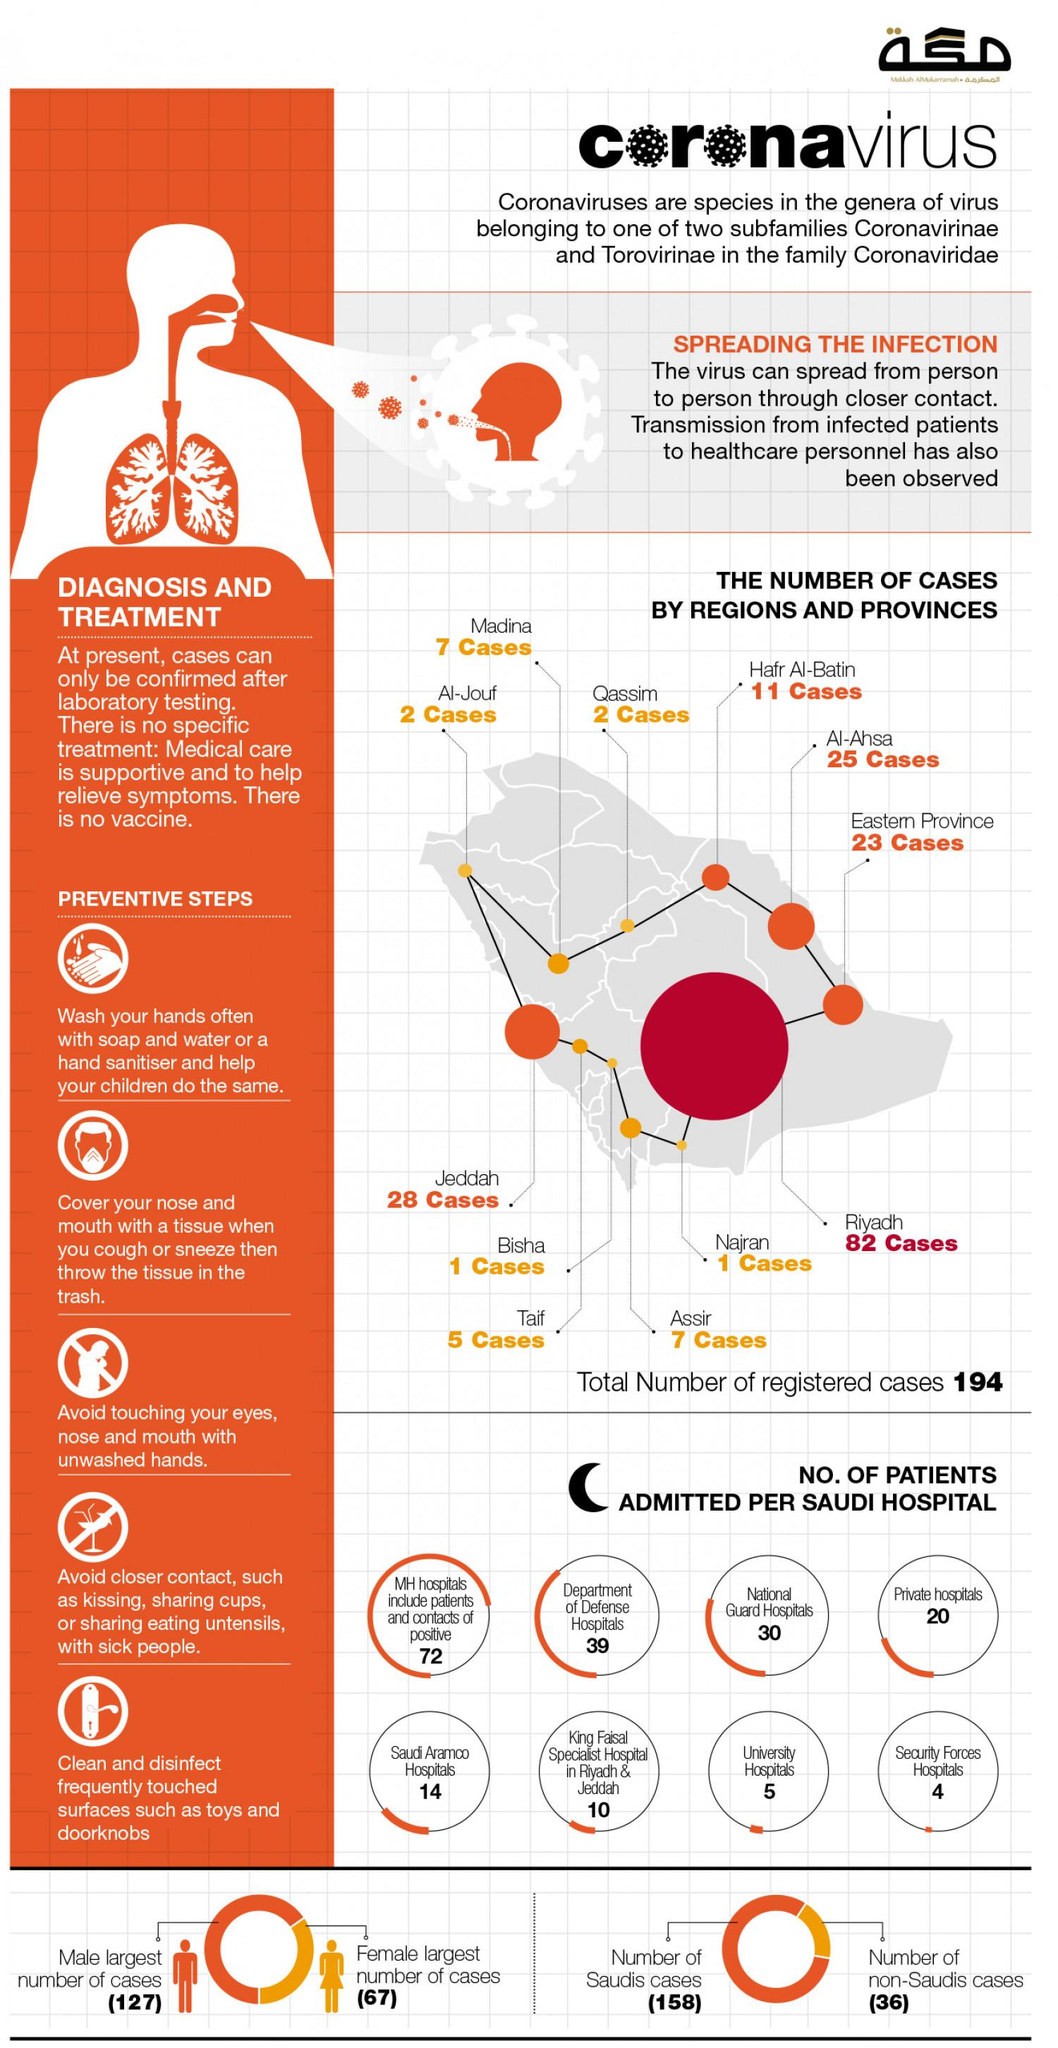Specify some key components in this picture. As of now, males account for 127 out of the total number of Covid-19 cases in Saudi Arabia. In Saudi Arabia, a total of 20,000 Covid patients were admitted to private hospitals. There have been 23 reported cases of Covid-19 in the eastern province of Saudi Arabia. Jeddah, the second largest city in Saudi Arabia, has reported the highest number of COVID-19 cases. As of February 18th, there are 158 confirmed cases of COVID-19 among Saudi nationals. 